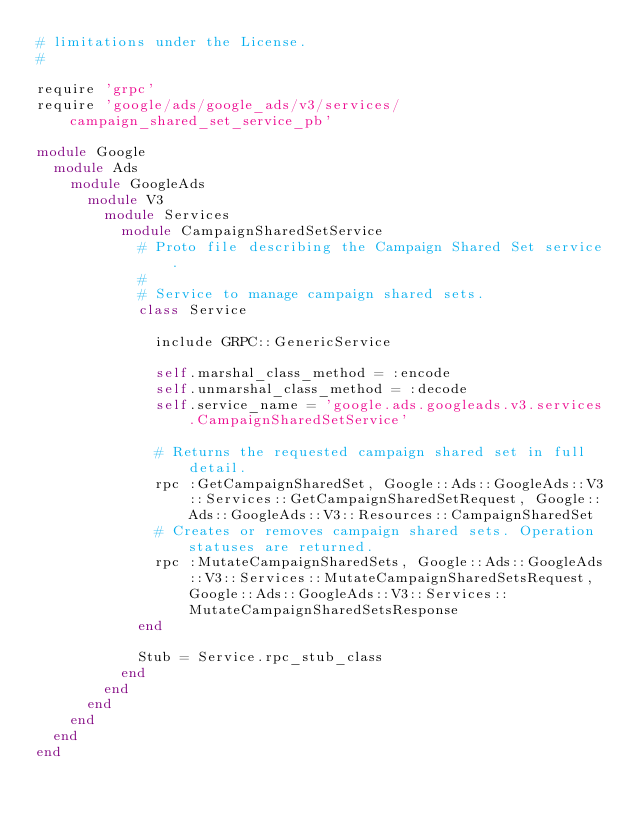<code> <loc_0><loc_0><loc_500><loc_500><_Ruby_># limitations under the License.
#

require 'grpc'
require 'google/ads/google_ads/v3/services/campaign_shared_set_service_pb'

module Google
  module Ads
    module GoogleAds
      module V3
        module Services
          module CampaignSharedSetService
            # Proto file describing the Campaign Shared Set service.
            #
            # Service to manage campaign shared sets.
            class Service

              include GRPC::GenericService

              self.marshal_class_method = :encode
              self.unmarshal_class_method = :decode
              self.service_name = 'google.ads.googleads.v3.services.CampaignSharedSetService'

              # Returns the requested campaign shared set in full detail.
              rpc :GetCampaignSharedSet, Google::Ads::GoogleAds::V3::Services::GetCampaignSharedSetRequest, Google::Ads::GoogleAds::V3::Resources::CampaignSharedSet
              # Creates or removes campaign shared sets. Operation statuses are returned.
              rpc :MutateCampaignSharedSets, Google::Ads::GoogleAds::V3::Services::MutateCampaignSharedSetsRequest, Google::Ads::GoogleAds::V3::Services::MutateCampaignSharedSetsResponse
            end

            Stub = Service.rpc_stub_class
          end
        end
      end
    end
  end
end
</code> 